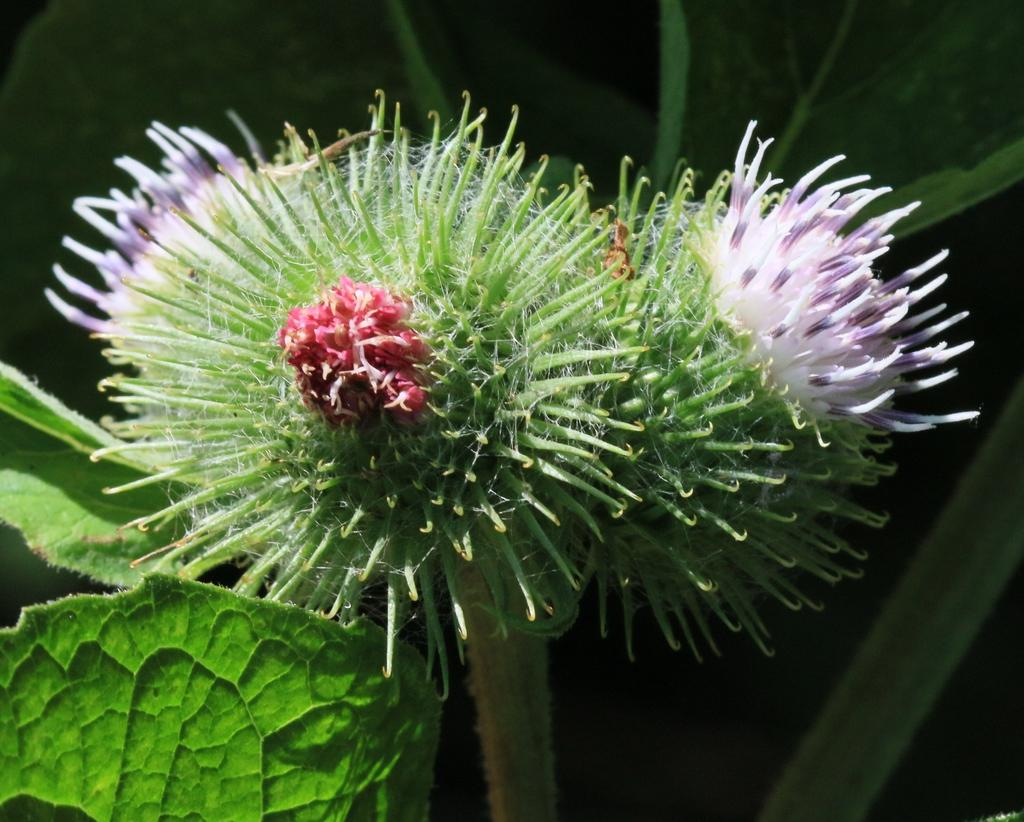What is present in the image? There is a plant in the image. What specific feature of the plant can be observed? The plant has flowers. Can you describe the background of the image? The background of the image is blurred. How many feet are visible in the image? There are no feet present in the image. What type of circle can be seen in the image? There is no circle present in the image. 